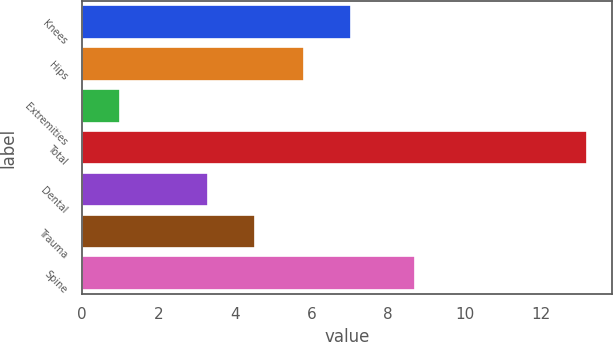<chart> <loc_0><loc_0><loc_500><loc_500><bar_chart><fcel>Knees<fcel>Hips<fcel>Extremities<fcel>Total<fcel>Dental<fcel>Trauma<fcel>Spine<nl><fcel>7.02<fcel>5.8<fcel>1<fcel>13.2<fcel>3.3<fcel>4.52<fcel>8.7<nl></chart> 